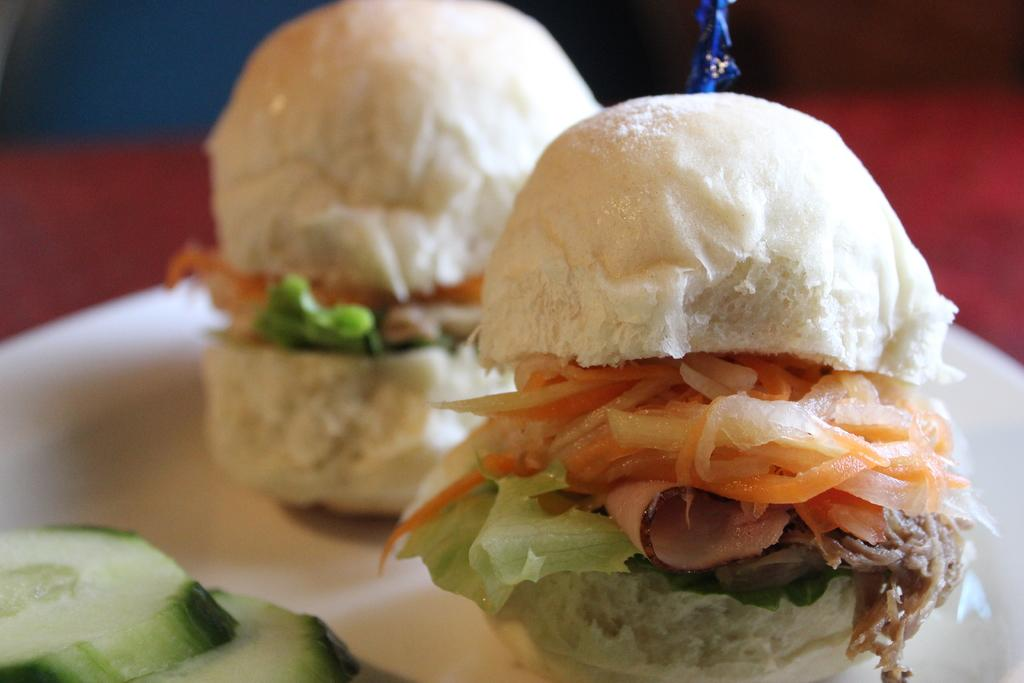What is on the plate that is visible in the image? There are food items on a plate in the image. Can you describe the background of the image? The background of the image is blurred. What is the slope of the hill in the image? There is no hill present in the image; it only features a plate with food items and a blurred background. 